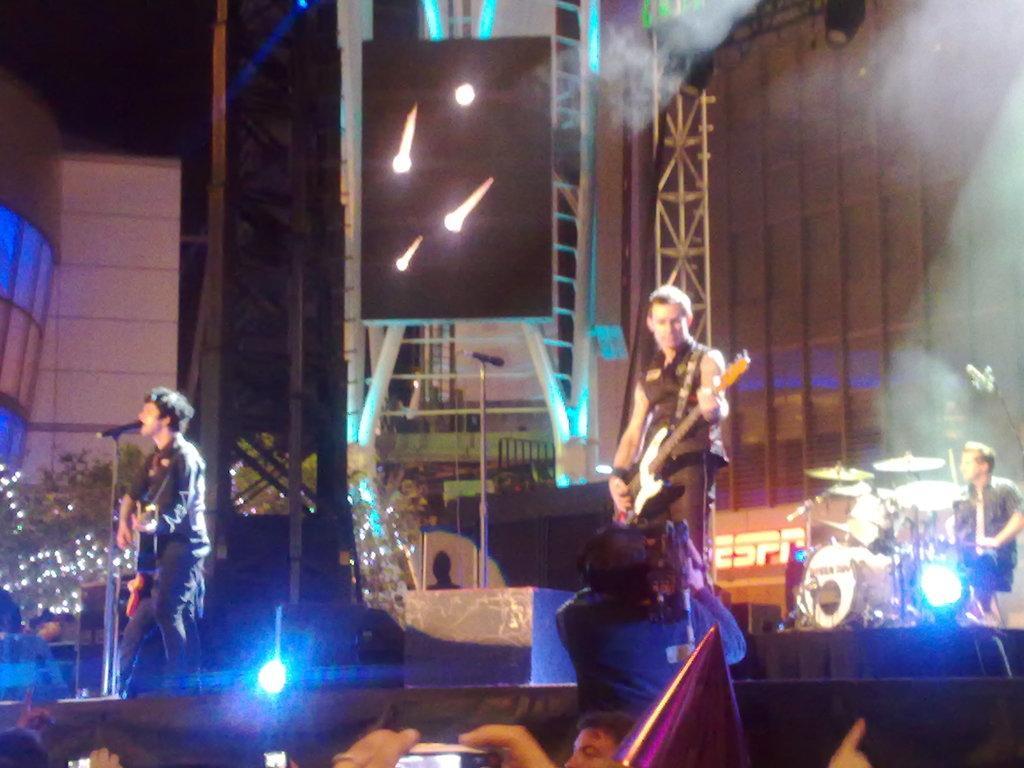How would you summarize this image in a sentence or two? In this image I see 3 men in which 2 of them are standing and holding their guitars and this man is sitting and is in front of the drums. I can also see few people over here and the lights. 